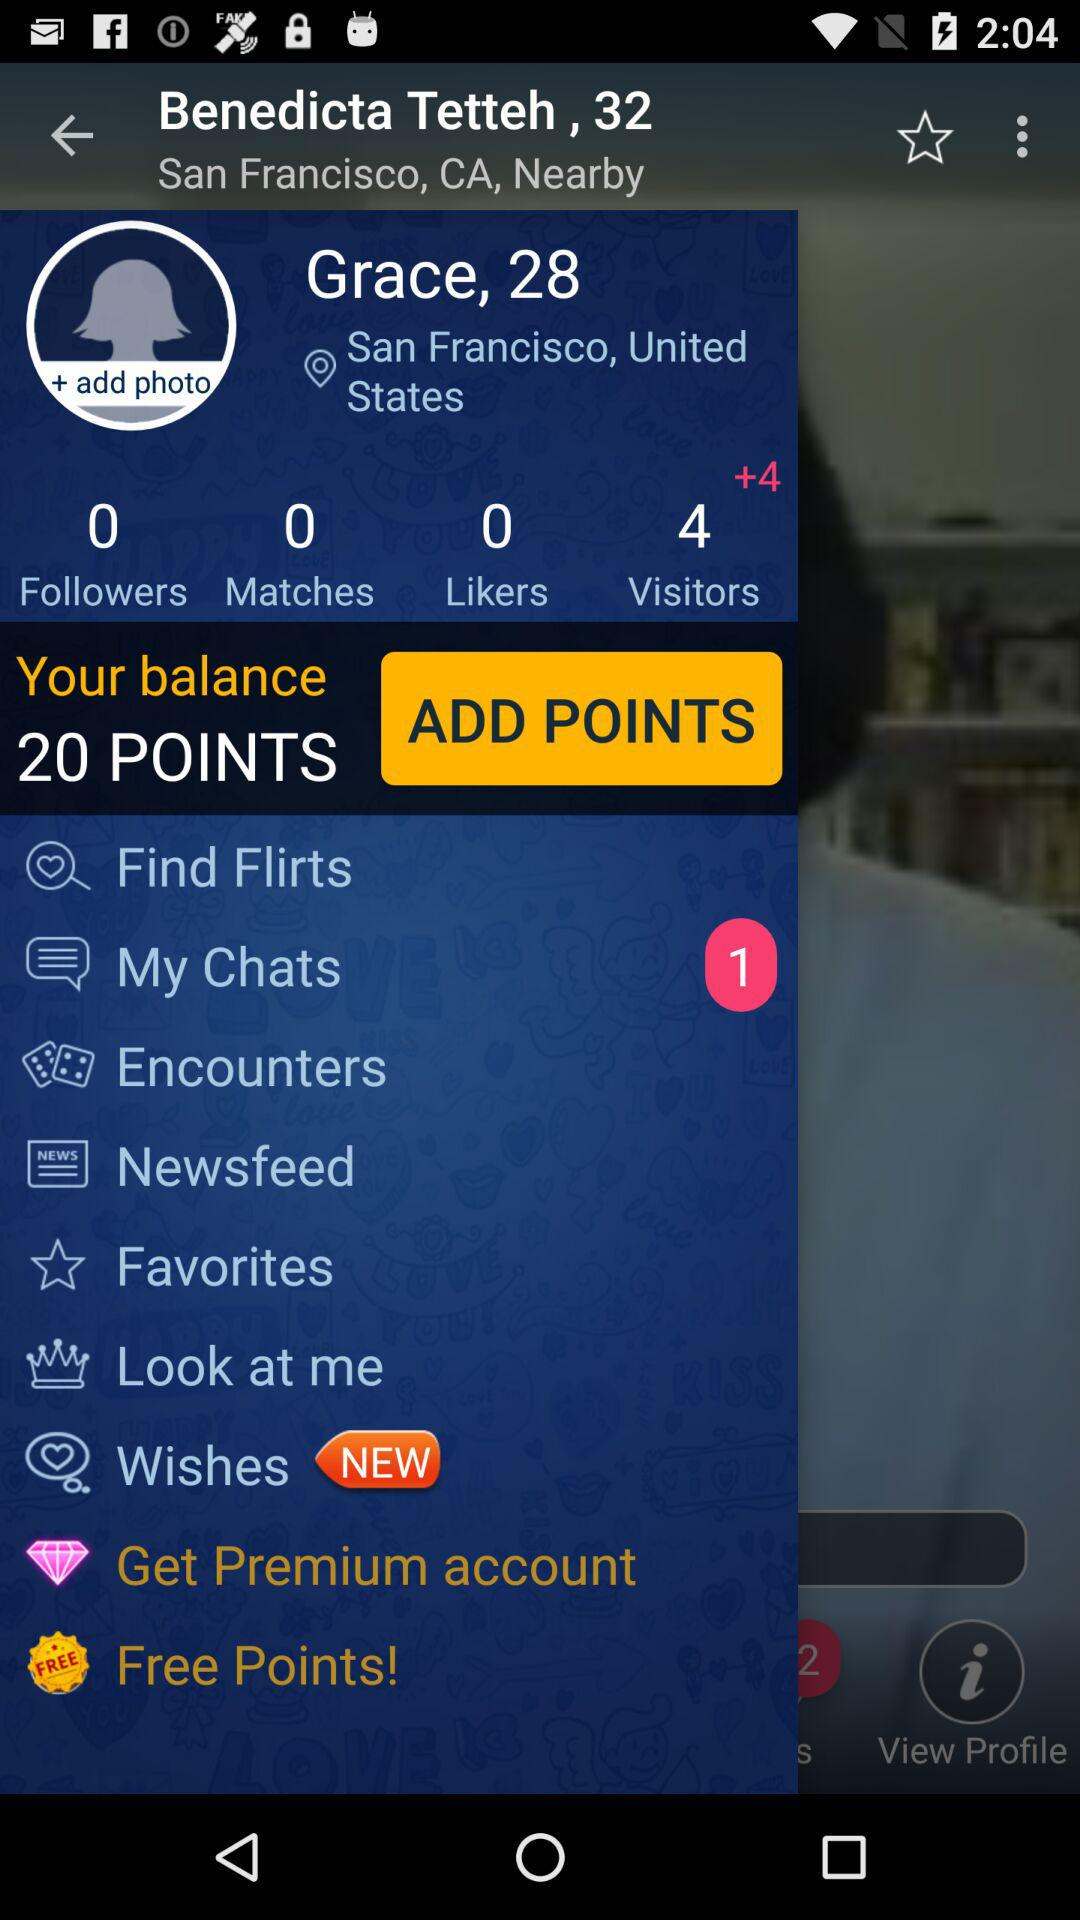How many visitors are there? There are 4 visitors. 